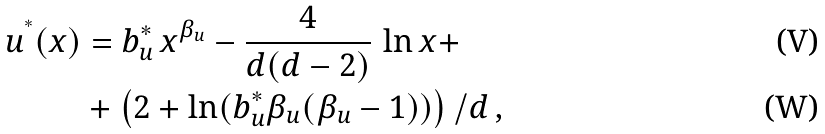Convert formula to latex. <formula><loc_0><loc_0><loc_500><loc_500>u ^ { ^ { * } } ( x ) & = b _ { u } ^ { * } \, x ^ { \beta _ { u } } - \frac { 4 } { d ( d - 2 ) } \, \ln x + \\ & + \left ( 2 + \ln ( b _ { u } ^ { * } \beta _ { u } ( \beta _ { u } - 1 ) ) \right ) / d \, ,</formula> 